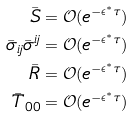<formula> <loc_0><loc_0><loc_500><loc_500>\bar { S } & = \mathcal { O } ( e ^ { - \epsilon ^ { * } \tau } ) \\ \bar { \sigma } _ { i j } \bar { \sigma } ^ { i j } & = \mathcal { O } ( e ^ { - \epsilon ^ { * } \tau } ) \\ \bar { R } & = \mathcal { O } ( e ^ { - \epsilon ^ { * } \tau } ) \\ \bar { T } _ { 0 0 } & = \mathcal { O } ( e ^ { - \epsilon ^ { * } \tau } )</formula> 